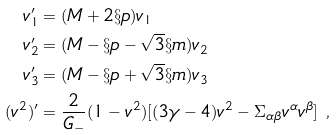<formula> <loc_0><loc_0><loc_500><loc_500>v _ { 1 } ^ { \prime } & = ( M + 2 \S p ) v _ { 1 } \\ v _ { 2 } ^ { \prime } & = ( M - \S p - \sqrt { 3 } \S m ) v _ { 2 } \\ v _ { 3 } ^ { \prime } & = ( M - \S p + \sqrt { 3 } \S m ) v _ { 3 } \\ ( v ^ { 2 } ) ^ { \prime } & = \frac { 2 } { G _ { - } } ( 1 - v ^ { 2 } ) [ ( 3 \gamma - 4 ) v ^ { 2 } - \Sigma _ { \alpha \beta } v ^ { \alpha } v ^ { \beta } ] \ ,</formula> 